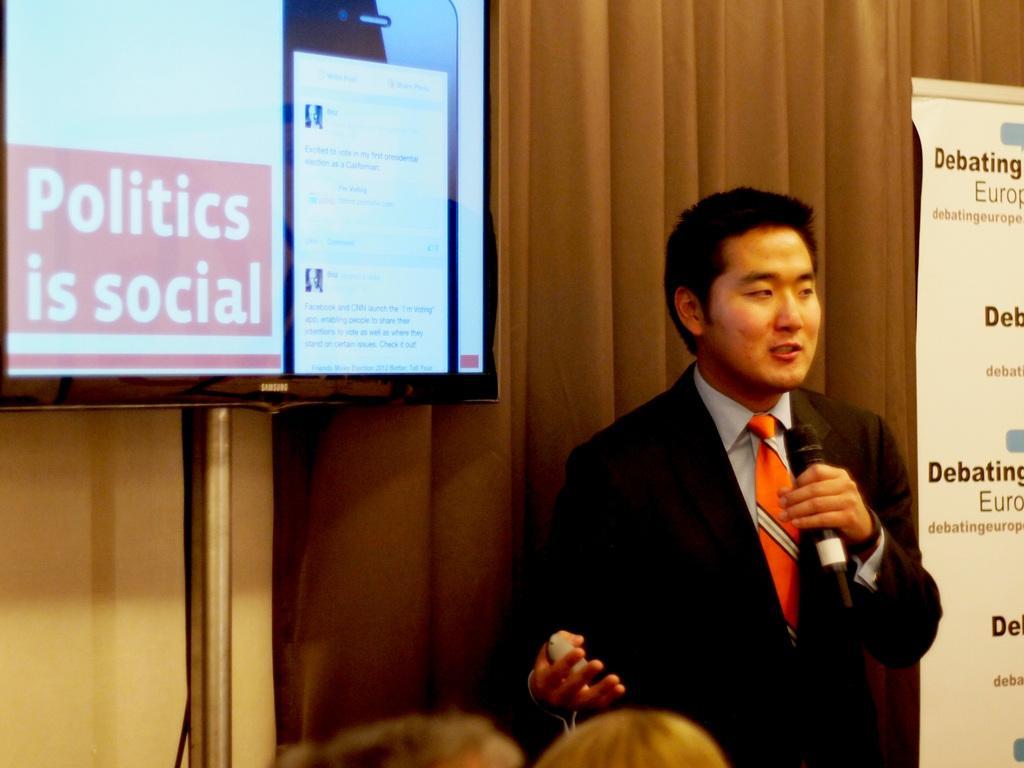In one or two sentences, can you explain what this image depicts? In this image we can see a man standing on the floor and holding mic in his hand. In the background there are advertisement, curtain and a display screen. 